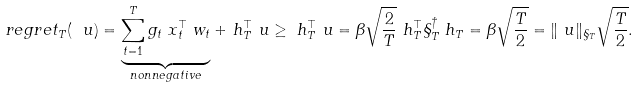Convert formula to latex. <formula><loc_0><loc_0><loc_500><loc_500>\ r e g r e t _ { T } ( \ u ) & = \underbrace { \sum _ { t = 1 } ^ { T } g _ { t } \ x _ { t } ^ { \top } \ w _ { t } } _ { n o n n e g a t i v e } + \ h _ { T } ^ { \top } \ u \geq \ h _ { T } ^ { \top } \ u = \beta \sqrt { \frac { 2 } { T } } \ h _ { T } ^ { \top } \S _ { T } ^ { \dagger } \ h _ { T } = \beta \sqrt { \frac { T } { 2 } } = \| \ u \| _ { \S _ { T } } \sqrt { \frac { T } { 2 } } .</formula> 